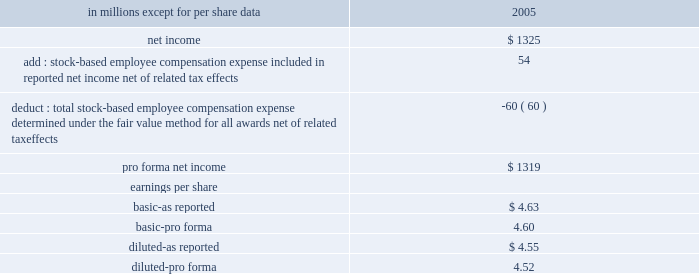Stock-based compensation we did not recognize stock-based employee compensation expense related to stock options granted before 2003 as permitted under accounting principles board opinion no .
25 , 201caccounting for stock issued to employees , 201d ( 201capb 25 201d ) .
Effective january 1 , 2003 , we adopted the fair value recognition provisions of sfas 123 , 201caccounting for stock- based compensation , 201d as amended by sfas 148 , 201caccounting for stock-based compensation-transition and disclosure , 201d prospectively to all employee awards granted , modified or settled after january 1 , 2003 .
We did not restate results for prior years upon our adoption of sfas 123 .
Since we adopted sfas 123 prospectively , the cost related to stock- based employee compensation included in net income for 2005 was less than what we would have recognized if we had applied the fair value based method to all awards since the original effective date of the standard .
In december 2004 , the fasb issued sfas 123r 201cshare- based payment , 201d which replaced sfas 123 and superseded apb 25 .
Sfas 123r requires compensation cost related to share-based payments to employees to be recognized in the financial statements based on their fair value .
We adopted sfas 123r effective january 1 , 2006 , using the modified prospective method of transition , which required the provisions of sfas 123r be applied to new awards and awards modified , repurchased or cancelled after the effective date .
It also required changes in the timing of expense recognition for awards granted to retirement-eligible employees and clarified the accounting for the tax effects of stock awards .
The adoption of sfas 123r did not have a significant impact on our consolidated financial statements .
The table shows the effect on 2005 net income and earnings per share if we had applied the fair value recognition provisions of sfas 123 , as amended , to all outstanding and unvested awards .
Pro forma net income and earnings per share ( a ) .
( a ) there were no differences between the gaap basis and pro forma basis of reporting 2006 net income and related per share amounts .
See note 18 stock-based compensation plans for additional information .
Recent accounting pronouncements in december 2007 , the fasb issued sfas 141 ( r ) , 201cbusiness combinations . 201d this statement will require all businesses acquired to be measured at the fair value of the consideration paid as opposed to the cost-based provisions of sfas 141 .
It will require an entity to recognize the assets acquired , the liabilities assumed , and any noncontrolling interest in the acquiree at the acquisition date , measured at their fair values as of that date .
Sfas 141 ( r ) requires the value of consideration paid including any future contingent consideration to be measured at fair value at the closing date of the transaction .
Also , restructuring costs and acquisition costs are to be expensed rather than included in the cost of the acquisition .
This guidance is effective for all acquisitions with closing dates after january 1 , 2009 .
In december 2007 , the fasb issued sfas 160 , 201caccounting and reporting of noncontrolling interests in consolidated financial statements , an amendment of arb no .
51 . 201d this statement amends arb no .
51 to establish accounting and reporting standards for the noncontrolling interest in a subsidiary and for the deconsolidation of a subsidiary .
It clarifies that a noncontrolling interest should be reported as equity in the consolidated financial statements .
This statement requires expanded disclosures that identify and distinguish between the interests of the parent 2019s owners and the interests of the noncontrolling owners of an entity .
This guidance is effective january 1 , 2009 .
We are currently analyzing the standard but do not expect the adoption to have a material impact on our consolidated financial statements .
In november 2007 , the sec issued staff accounting bulletin ( 201csab 201d ) no .
109 , that provides guidance regarding measuring the fair value of recorded written loan commitments .
The guidance indicates that the expected future cash flows related to servicing should be included in the fair value measurement of all written loan commitments that are accounted for at fair value through earnings .
Sab 109 is effective january 1 , 2008 , prospectively to loan commitments issued or modified after that date .
The adoption of this guidance is not expected to have a material effect on our results of operations or financial position .
In june 2007 , the aicpa issued statement of position 07-1 , 201cclarification of the scope of the audit and accounting guide 201cinvestment companies 201d and accounting by parent companies and equity method investors for investments in investment companies 201d ( 201csop 07-1 201d ) .
This statement provides guidance for determining whether an entity is within the scope of the aicpa audit and accounting guide investment companies ( 201cguide 201d ) and whether the specialized industry accounting principles of the guide should be retained in the financial statements of a parent company of an investment company or an equity method investor in an .
In millions , what were total adjustment to arrive at pro forma net income? 
Computations: (54 - 60)
Answer: -6.0. 